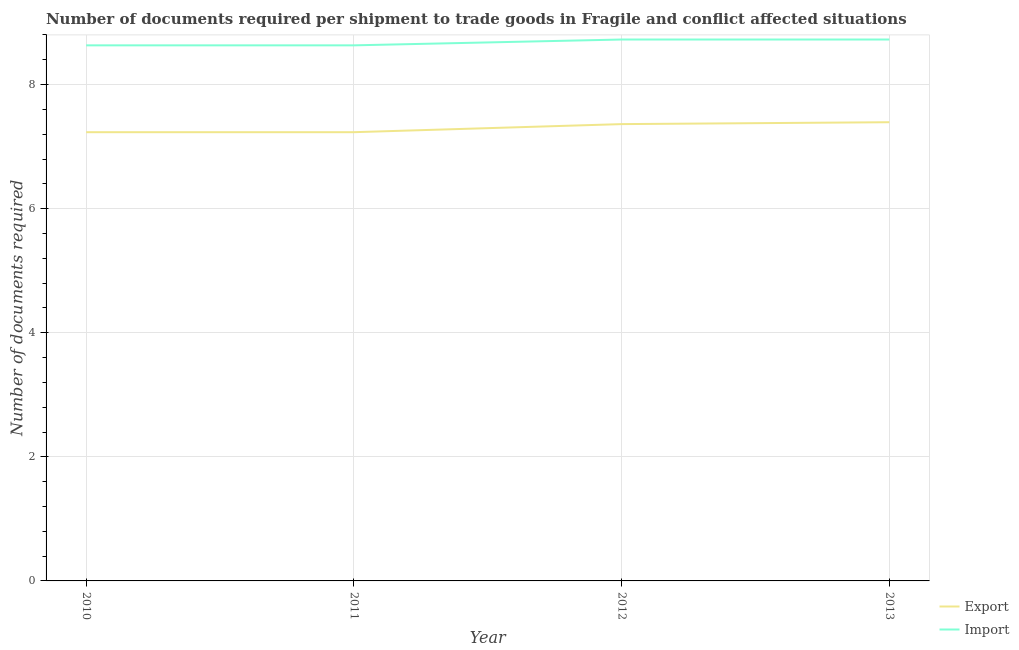How many different coloured lines are there?
Provide a succinct answer. 2. What is the number of documents required to export goods in 2013?
Provide a short and direct response. 7.39. Across all years, what is the maximum number of documents required to export goods?
Your answer should be compact. 7.39. Across all years, what is the minimum number of documents required to import goods?
Your answer should be very brief. 8.63. In which year was the number of documents required to export goods maximum?
Keep it short and to the point. 2013. In which year was the number of documents required to export goods minimum?
Ensure brevity in your answer.  2010. What is the total number of documents required to import goods in the graph?
Keep it short and to the point. 34.72. What is the difference between the number of documents required to export goods in 2011 and that in 2012?
Provide a succinct answer. -0.13. What is the difference between the number of documents required to export goods in 2012 and the number of documents required to import goods in 2011?
Offer a terse response. -1.27. What is the average number of documents required to export goods per year?
Provide a short and direct response. 7.31. In the year 2010, what is the difference between the number of documents required to export goods and number of documents required to import goods?
Make the answer very short. -1.4. In how many years, is the number of documents required to export goods greater than 5.2?
Provide a short and direct response. 4. What is the ratio of the number of documents required to import goods in 2011 to that in 2013?
Make the answer very short. 0.99. Is the number of documents required to export goods in 2010 less than that in 2011?
Provide a short and direct response. No. What is the difference between the highest and the second highest number of documents required to import goods?
Your answer should be very brief. 0. What is the difference between the highest and the lowest number of documents required to import goods?
Provide a short and direct response. 0.09. Does the number of documents required to import goods monotonically increase over the years?
Your answer should be compact. No. Is the number of documents required to export goods strictly greater than the number of documents required to import goods over the years?
Give a very brief answer. No. Is the number of documents required to export goods strictly less than the number of documents required to import goods over the years?
Make the answer very short. Yes. How many lines are there?
Provide a short and direct response. 2. How many years are there in the graph?
Give a very brief answer. 4. Are the values on the major ticks of Y-axis written in scientific E-notation?
Your answer should be compact. No. Does the graph contain any zero values?
Offer a terse response. No. Does the graph contain grids?
Make the answer very short. Yes. Where does the legend appear in the graph?
Your answer should be compact. Bottom right. What is the title of the graph?
Make the answer very short. Number of documents required per shipment to trade goods in Fragile and conflict affected situations. Does "Food and tobacco" appear as one of the legend labels in the graph?
Offer a terse response. No. What is the label or title of the X-axis?
Your answer should be very brief. Year. What is the label or title of the Y-axis?
Provide a short and direct response. Number of documents required. What is the Number of documents required of Export in 2010?
Offer a very short reply. 7.23. What is the Number of documents required of Import in 2010?
Make the answer very short. 8.63. What is the Number of documents required in Export in 2011?
Offer a terse response. 7.23. What is the Number of documents required of Import in 2011?
Offer a terse response. 8.63. What is the Number of documents required of Export in 2012?
Make the answer very short. 7.36. What is the Number of documents required in Import in 2012?
Your answer should be compact. 8.73. What is the Number of documents required of Export in 2013?
Offer a terse response. 7.39. What is the Number of documents required in Import in 2013?
Make the answer very short. 8.73. Across all years, what is the maximum Number of documents required of Export?
Offer a terse response. 7.39. Across all years, what is the maximum Number of documents required of Import?
Give a very brief answer. 8.73. Across all years, what is the minimum Number of documents required in Export?
Provide a short and direct response. 7.23. Across all years, what is the minimum Number of documents required in Import?
Your answer should be very brief. 8.63. What is the total Number of documents required of Export in the graph?
Your answer should be very brief. 29.22. What is the total Number of documents required of Import in the graph?
Your answer should be very brief. 34.72. What is the difference between the Number of documents required in Import in 2010 and that in 2011?
Offer a very short reply. 0. What is the difference between the Number of documents required in Export in 2010 and that in 2012?
Give a very brief answer. -0.13. What is the difference between the Number of documents required of Import in 2010 and that in 2012?
Provide a short and direct response. -0.09. What is the difference between the Number of documents required in Export in 2010 and that in 2013?
Make the answer very short. -0.16. What is the difference between the Number of documents required in Import in 2010 and that in 2013?
Make the answer very short. -0.09. What is the difference between the Number of documents required in Export in 2011 and that in 2012?
Your answer should be compact. -0.13. What is the difference between the Number of documents required in Import in 2011 and that in 2012?
Provide a short and direct response. -0.09. What is the difference between the Number of documents required in Export in 2011 and that in 2013?
Make the answer very short. -0.16. What is the difference between the Number of documents required in Import in 2011 and that in 2013?
Keep it short and to the point. -0.09. What is the difference between the Number of documents required in Export in 2012 and that in 2013?
Offer a very short reply. -0.03. What is the difference between the Number of documents required in Export in 2010 and the Number of documents required in Import in 2011?
Give a very brief answer. -1.4. What is the difference between the Number of documents required in Export in 2010 and the Number of documents required in Import in 2012?
Provide a succinct answer. -1.49. What is the difference between the Number of documents required in Export in 2010 and the Number of documents required in Import in 2013?
Keep it short and to the point. -1.49. What is the difference between the Number of documents required in Export in 2011 and the Number of documents required in Import in 2012?
Your answer should be very brief. -1.49. What is the difference between the Number of documents required of Export in 2011 and the Number of documents required of Import in 2013?
Offer a very short reply. -1.49. What is the difference between the Number of documents required in Export in 2012 and the Number of documents required in Import in 2013?
Your answer should be very brief. -1.36. What is the average Number of documents required in Export per year?
Offer a terse response. 7.31. What is the average Number of documents required of Import per year?
Offer a very short reply. 8.68. In the year 2010, what is the difference between the Number of documents required in Export and Number of documents required in Import?
Provide a succinct answer. -1.4. In the year 2011, what is the difference between the Number of documents required of Export and Number of documents required of Import?
Keep it short and to the point. -1.4. In the year 2012, what is the difference between the Number of documents required in Export and Number of documents required in Import?
Offer a terse response. -1.36. In the year 2013, what is the difference between the Number of documents required of Export and Number of documents required of Import?
Give a very brief answer. -1.33. What is the ratio of the Number of documents required of Export in 2010 to that in 2011?
Keep it short and to the point. 1. What is the ratio of the Number of documents required in Import in 2010 to that in 2011?
Make the answer very short. 1. What is the ratio of the Number of documents required in Export in 2010 to that in 2012?
Your answer should be very brief. 0.98. What is the ratio of the Number of documents required in Import in 2010 to that in 2012?
Your response must be concise. 0.99. What is the ratio of the Number of documents required of Export in 2010 to that in 2013?
Offer a very short reply. 0.98. What is the ratio of the Number of documents required of Import in 2010 to that in 2013?
Your response must be concise. 0.99. What is the ratio of the Number of documents required of Export in 2011 to that in 2012?
Keep it short and to the point. 0.98. What is the ratio of the Number of documents required of Import in 2011 to that in 2012?
Keep it short and to the point. 0.99. What is the ratio of the Number of documents required of Export in 2011 to that in 2013?
Your answer should be compact. 0.98. What is the ratio of the Number of documents required in Import in 2011 to that in 2013?
Ensure brevity in your answer.  0.99. What is the ratio of the Number of documents required of Export in 2012 to that in 2013?
Keep it short and to the point. 1. What is the ratio of the Number of documents required in Import in 2012 to that in 2013?
Provide a short and direct response. 1. What is the difference between the highest and the second highest Number of documents required in Export?
Offer a very short reply. 0.03. What is the difference between the highest and the second highest Number of documents required of Import?
Offer a terse response. 0. What is the difference between the highest and the lowest Number of documents required in Export?
Keep it short and to the point. 0.16. What is the difference between the highest and the lowest Number of documents required in Import?
Your answer should be compact. 0.09. 